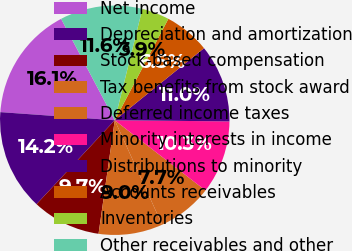Convert chart. <chart><loc_0><loc_0><loc_500><loc_500><pie_chart><fcel>Net income<fcel>Depreciation and amortization<fcel>Stock-based compensation<fcel>Tax benefits from stock award<fcel>Deferred income taxes<fcel>Minority interests in income<fcel>Distributions to minority<fcel>Accounts receivables<fcel>Inventories<fcel>Other receivables and other<nl><fcel>16.13%<fcel>14.19%<fcel>9.68%<fcel>9.03%<fcel>7.74%<fcel>10.32%<fcel>10.97%<fcel>6.45%<fcel>3.87%<fcel>11.61%<nl></chart> 